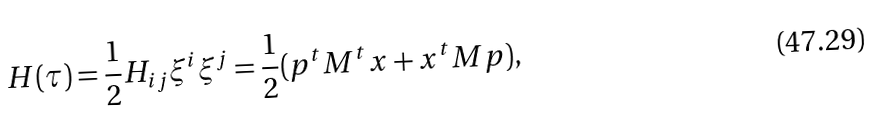Convert formula to latex. <formula><loc_0><loc_0><loc_500><loc_500>H ( { \tau } ) = \frac { 1 } { 2 } H _ { i j } { \xi } ^ { i } { \xi } ^ { j } = \frac { 1 } { 2 } ( p ^ { t } M ^ { t } x + x ^ { t } M p ) ,</formula> 